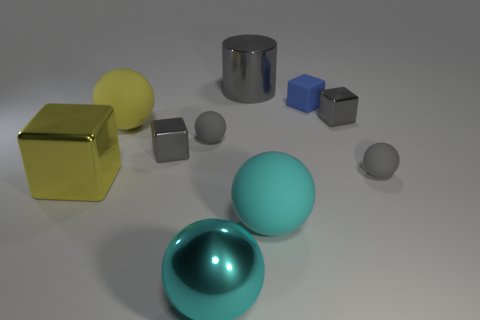Comparing the sizes of the yellow and blue cubes, which one seems larger, and by how much? The yellow cube seems significantly larger than the blue cube. Although it's difficult to determine the exact difference without measurements, visually, the yellow cube could be approximately twice as large in volume compared to the blue cube. 